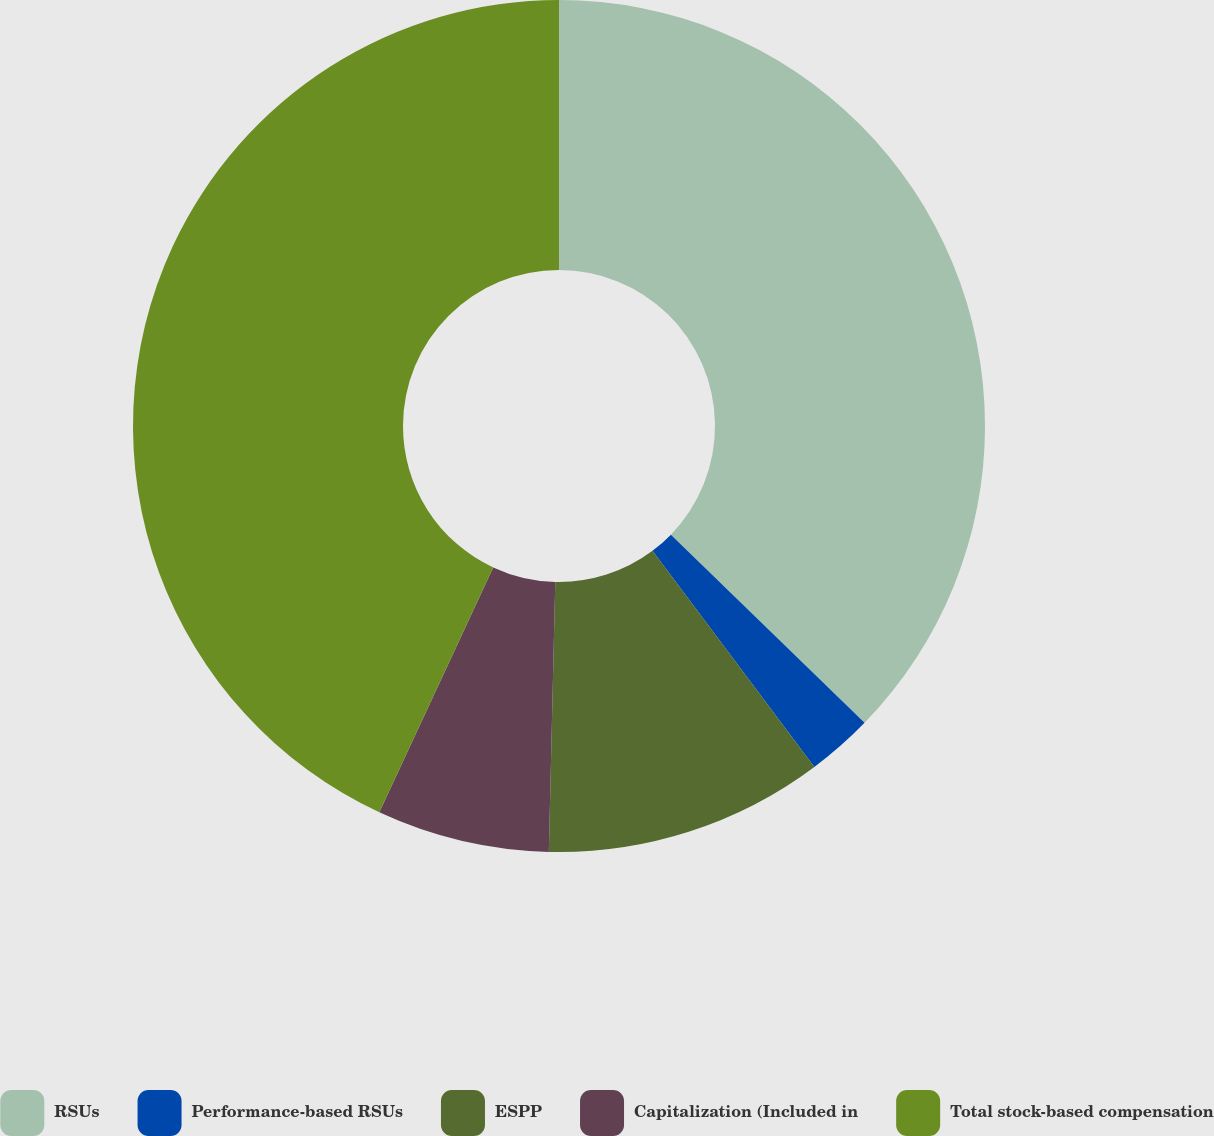<chart> <loc_0><loc_0><loc_500><loc_500><pie_chart><fcel>RSUs<fcel>Performance-based RSUs<fcel>ESPP<fcel>Capitalization (Included in<fcel>Total stock-based compensation<nl><fcel>37.27%<fcel>2.5%<fcel>10.61%<fcel>6.55%<fcel>43.07%<nl></chart> 